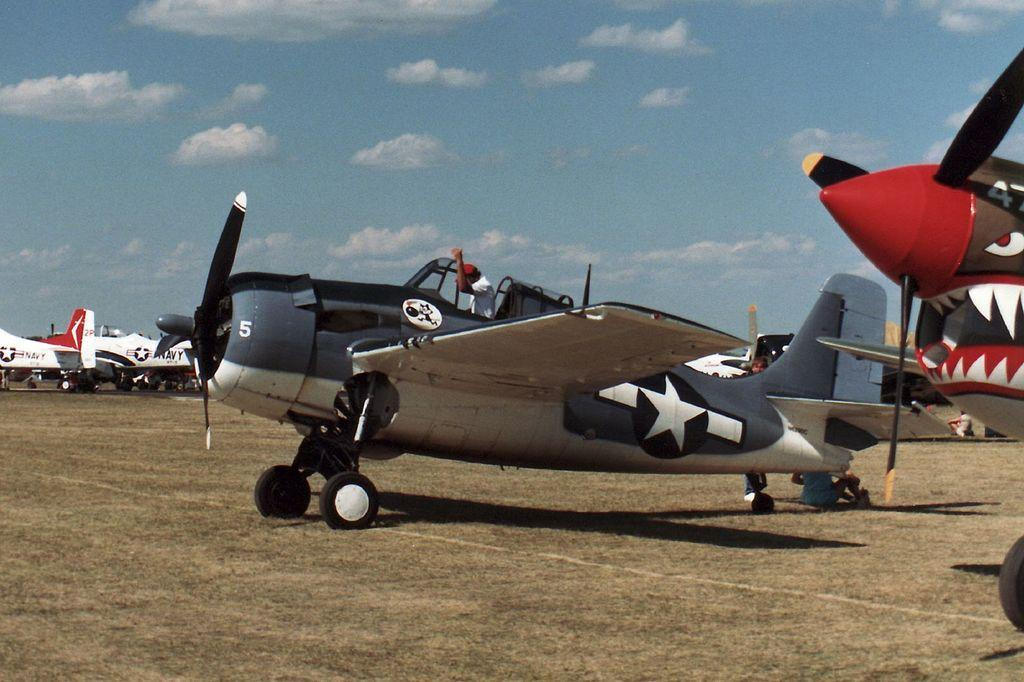What type of vehicles are on the ground in the image? There are planes on the ground in the image. What is the person in the image doing? A person is sitting on one of the planes. Can you describe the people visible in the background of the image? There are people visible in the background of the image. What can be seen in the sky in the background of the image? Clouds are present in the sky in the background of the image. What type of corn is being smashed in the cemetery in the image? There is no corn or cemetery present in the image; it features planes on the ground with a person sitting on one of them and people visible in the background. 